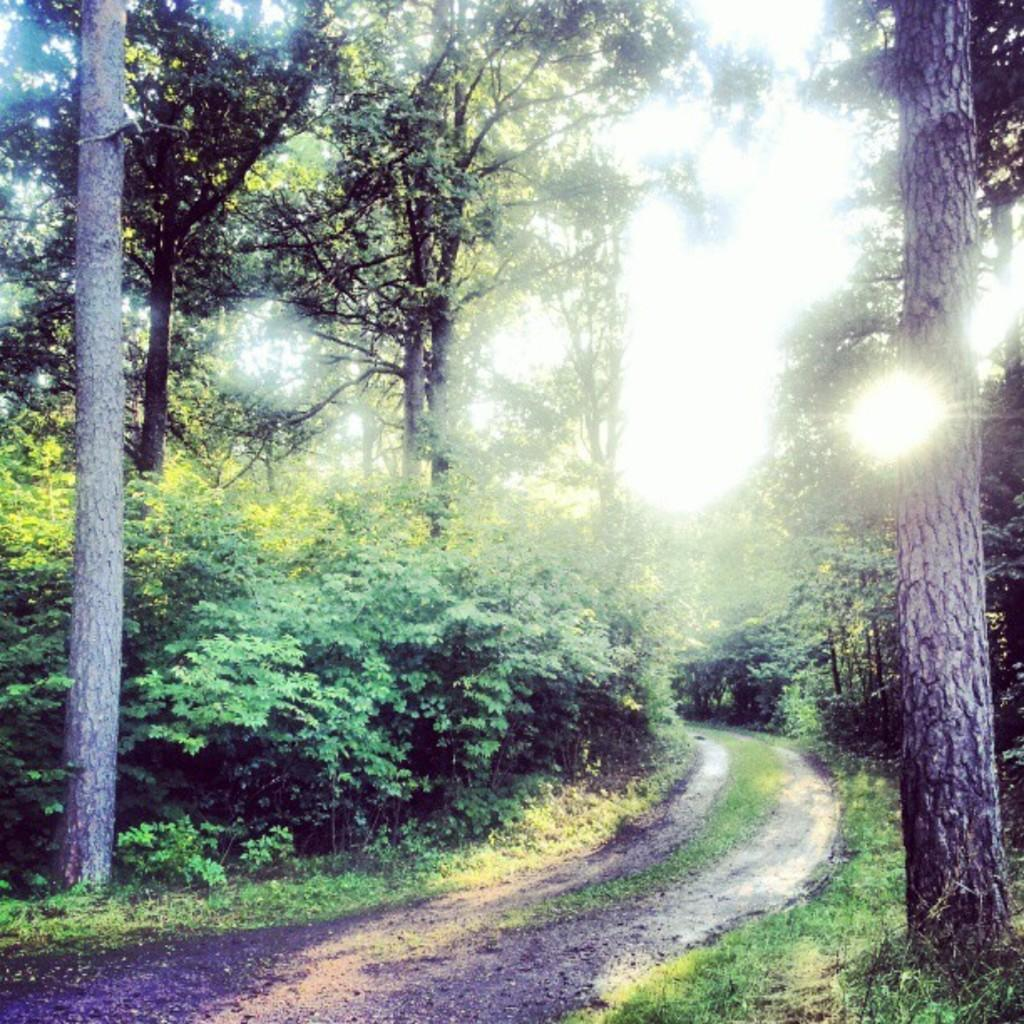What type of vegetation can be seen in the image? There are trees and plants in the image. What surface can be used for walking or traveling in the image? There is a path in the image that can be used for walking or traveling. What type of ground cover is present in the image? There is grass in the image. Where is the light bulb located in the image? There is no light bulb present in the image. What type of group is gathered in the image? There is no group of people present in the image. 